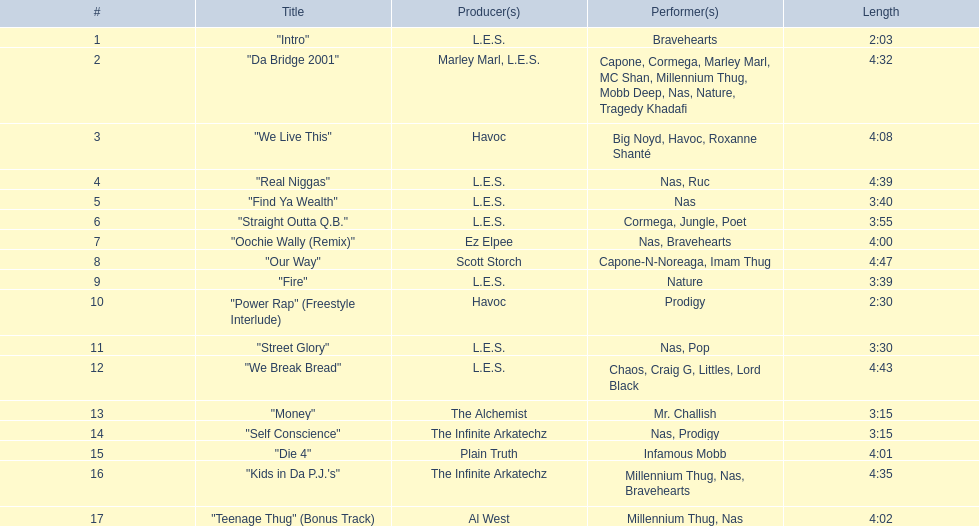What song is listed following "street glory"? "We Break Bread". Parse the table in full. {'header': ['#', 'Title', 'Producer(s)', 'Performer(s)', 'Length'], 'rows': [['1', '"Intro"', 'L.E.S.', 'Bravehearts', '2:03'], ['2', '"Da Bridge 2001"', 'Marley Marl, L.E.S.', 'Capone, Cormega, Marley Marl, MC Shan, Millennium Thug, Mobb Deep, Nas, Nature, Tragedy Khadafi', '4:32'], ['3', '"We Live This"', 'Havoc', 'Big Noyd, Havoc, Roxanne Shanté', '4:08'], ['4', '"Real Niggas"', 'L.E.S.', 'Nas, Ruc', '4:39'], ['5', '"Find Ya Wealth"', 'L.E.S.', 'Nas', '3:40'], ['6', '"Straight Outta Q.B."', 'L.E.S.', 'Cormega, Jungle, Poet', '3:55'], ['7', '"Oochie Wally (Remix)"', 'Ez Elpee', 'Nas, Bravehearts', '4:00'], ['8', '"Our Way"', 'Scott Storch', 'Capone-N-Noreaga, Imam Thug', '4:47'], ['9', '"Fire"', 'L.E.S.', 'Nature', '3:39'], ['10', '"Power Rap" (Freestyle Interlude)', 'Havoc', 'Prodigy', '2:30'], ['11', '"Street Glory"', 'L.E.S.', 'Nas, Pop', '3:30'], ['12', '"We Break Bread"', 'L.E.S.', 'Chaos, Craig G, Littles, Lord Black', '4:43'], ['13', '"Money"', 'The Alchemist', 'Mr. Challish', '3:15'], ['14', '"Self Conscience"', 'The Infinite Arkatechz', 'Nas, Prodigy', '3:15'], ['15', '"Die 4"', 'Plain Truth', 'Infamous Mobb', '4:01'], ['16', '"Kids in Da P.J.\'s"', 'The Infinite Arkatechz', 'Millennium Thug, Nas, Bravehearts', '4:35'], ['17', '"Teenage Thug" (Bonus Track)', 'Al West', 'Millennium Thug, Nas', '4:02']]} 